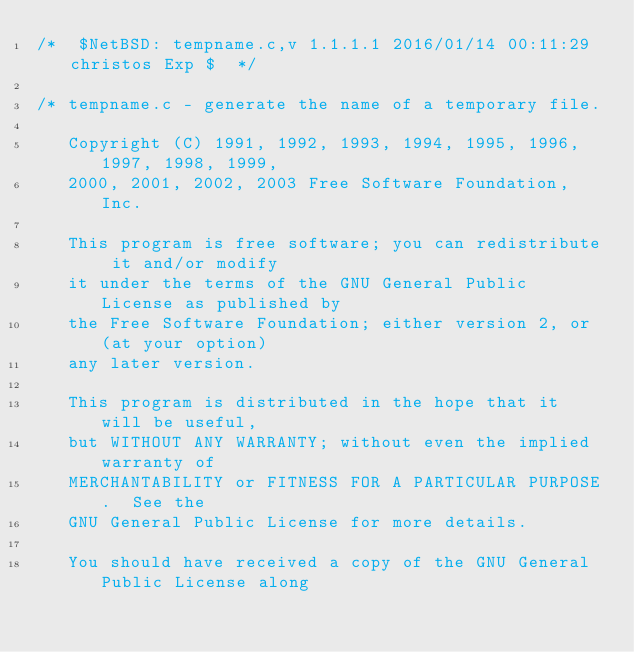<code> <loc_0><loc_0><loc_500><loc_500><_C_>/*	$NetBSD: tempname.c,v 1.1.1.1 2016/01/14 00:11:29 christos Exp $	*/

/* tempname.c - generate the name of a temporary file.

   Copyright (C) 1991, 1992, 1993, 1994, 1995, 1996, 1997, 1998, 1999,
   2000, 2001, 2002, 2003 Free Software Foundation, Inc.

   This program is free software; you can redistribute it and/or modify
   it under the terms of the GNU General Public License as published by
   the Free Software Foundation; either version 2, or (at your option)
   any later version.

   This program is distributed in the hope that it will be useful,
   but WITHOUT ANY WARRANTY; without even the implied warranty of
   MERCHANTABILITY or FITNESS FOR A PARTICULAR PURPOSE.  See the
   GNU General Public License for more details.

   You should have received a copy of the GNU General Public License along</code> 